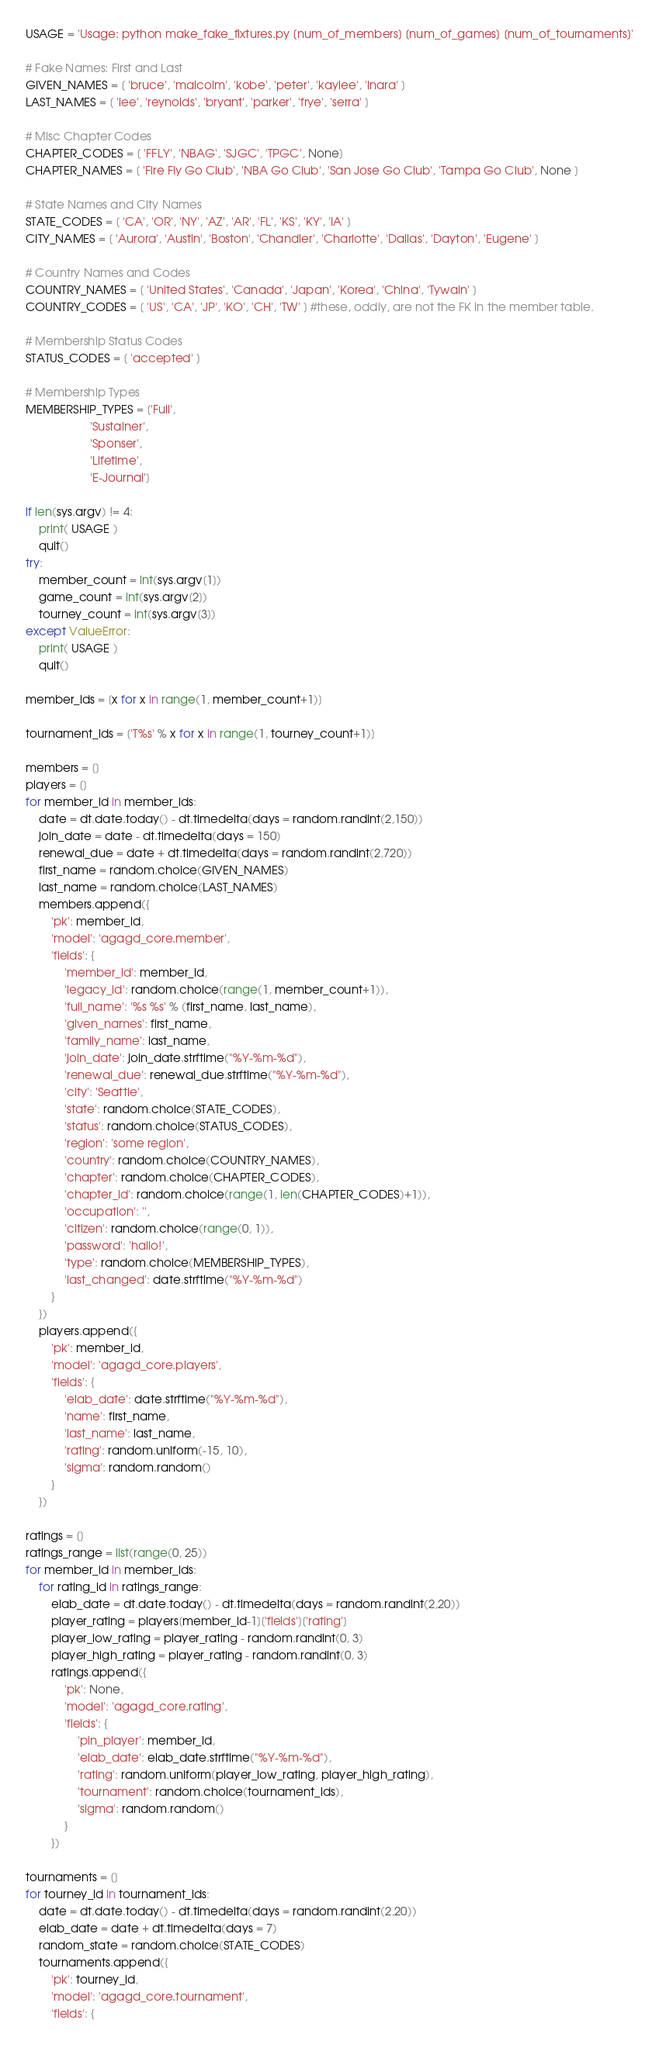<code> <loc_0><loc_0><loc_500><loc_500><_Python_>USAGE = 'Usage: python make_fake_fixtures.py [num_of_members] [num_of_games] [num_of_tournaments]'

# Fake Names: First and Last
GIVEN_NAMES = [ 'bruce', 'malcolm', 'kobe', 'peter', 'kaylee', 'inara' ]
LAST_NAMES = [ 'lee', 'reynolds', 'bryant', 'parker', 'frye', 'serra' ]

# Misc Chapter Codes
CHAPTER_CODES = [ 'FFLY', 'NBAG', 'SJGC', 'TPGC', None]
CHAPTER_NAMES = [ 'Fire Fly Go Club', 'NBA Go Club', 'San Jose Go Club', 'Tampa Go Club', None ]

# State Names and City Names
STATE_CODES = [ 'CA', 'OR', 'NY', 'AZ', 'AR', 'FL', 'KS', 'KY', 'IA' ]
CITY_NAMES = [ 'Aurora', 'Austin', 'Boston', 'Chandler', 'Charlotte', 'Dallas', 'Dayton', 'Eugene' ]

# Country Names and Codes
COUNTRY_NAMES = [ 'United States', 'Canada', 'Japan', 'Korea', 'China', 'Tywain' ]
COUNTRY_CODES = [ 'US', 'CA', 'JP', 'KO', 'CH', 'TW' ] #these, oddly, are not the FK in the member table.

# Membership Status Codes
STATUS_CODES = [ 'accepted' ]

# Membership Types
MEMBERSHIP_TYPES = ['Full',
                    'Sustainer',
                    'Sponser',
                    'Lifetime',
                    'E-Journal']

if len(sys.argv) != 4:
    print( USAGE )
    quit()
try:
    member_count = int(sys.argv[1])
    game_count = int(sys.argv[2])
    tourney_count = int(sys.argv[3])
except ValueError:
    print( USAGE )
    quit()

member_ids = [x for x in range(1, member_count+1)]

tournament_ids = ['T%s' % x for x in range(1, tourney_count+1)]

members = []
players = []
for member_id in member_ids:
    date = dt.date.today() - dt.timedelta(days = random.randint(2,150))
    join_date = date - dt.timedelta(days = 150)
    renewal_due = date + dt.timedelta(days = random.randint(2,720))
    first_name = random.choice(GIVEN_NAMES)
    last_name = random.choice(LAST_NAMES)
    members.append({
        'pk': member_id,
        'model': 'agagd_core.member',
        'fields': {
            'member_id': member_id,
            'legacy_id': random.choice(range(1, member_count+1)),
            'full_name': '%s %s' % (first_name, last_name),
            'given_names': first_name,
            'family_name': last_name,
            'join_date': join_date.strftime("%Y-%m-%d"),
            'renewal_due': renewal_due.strftime("%Y-%m-%d"),
            'city': 'Seattle',
            'state': random.choice(STATE_CODES),
            'status': random.choice(STATUS_CODES),
            'region': 'some region',
            'country': random.choice(COUNTRY_NAMES),
            'chapter': random.choice(CHAPTER_CODES),
            'chapter_id': random.choice(range(1, len(CHAPTER_CODES)+1)),
            'occupation': '',
            'citizen': random.choice(range(0, 1)),
            'password': 'hallo!',
            'type': random.choice(MEMBERSHIP_TYPES),
            'last_changed': date.strftime("%Y-%m-%d")
        }
    })
    players.append({
        'pk': member_id,
        'model': 'agagd_core.players',
        'fields': {
            'elab_date': date.strftime("%Y-%m-%d"),
            'name': first_name,
            'last_name': last_name,
            'rating': random.uniform(-15, 10),
            'sigma': random.random()
        }
    })

ratings = []
ratings_range = list(range(0, 25))
for member_id in member_ids:
    for rating_id in ratings_range:
        elab_date = dt.date.today() - dt.timedelta(days = random.randint(2,20))
        player_rating = players[member_id-1]['fields']['rating']
        player_low_rating = player_rating - random.randint(0, 3)
        player_high_rating = player_rating - random.randint(0, 3)
        ratings.append({
            'pk': None,
            'model': 'agagd_core.rating',
            'fields': {
                'pin_player': member_id,
                'elab_date': elab_date.strftime("%Y-%m-%d"),
                'rating': random.uniform(player_low_rating, player_high_rating),
                'tournament': random.choice(tournament_ids),
                'sigma': random.random()
            }
        })

tournaments = []
for tourney_id in tournament_ids:
    date = dt.date.today() - dt.timedelta(days = random.randint(2,20))
    elab_date = date + dt.timedelta(days = 7)
    random_state = random.choice(STATE_CODES)
    tournaments.append({
        'pk': tourney_id,
        'model': 'agagd_core.tournament',
        'fields': {</code> 